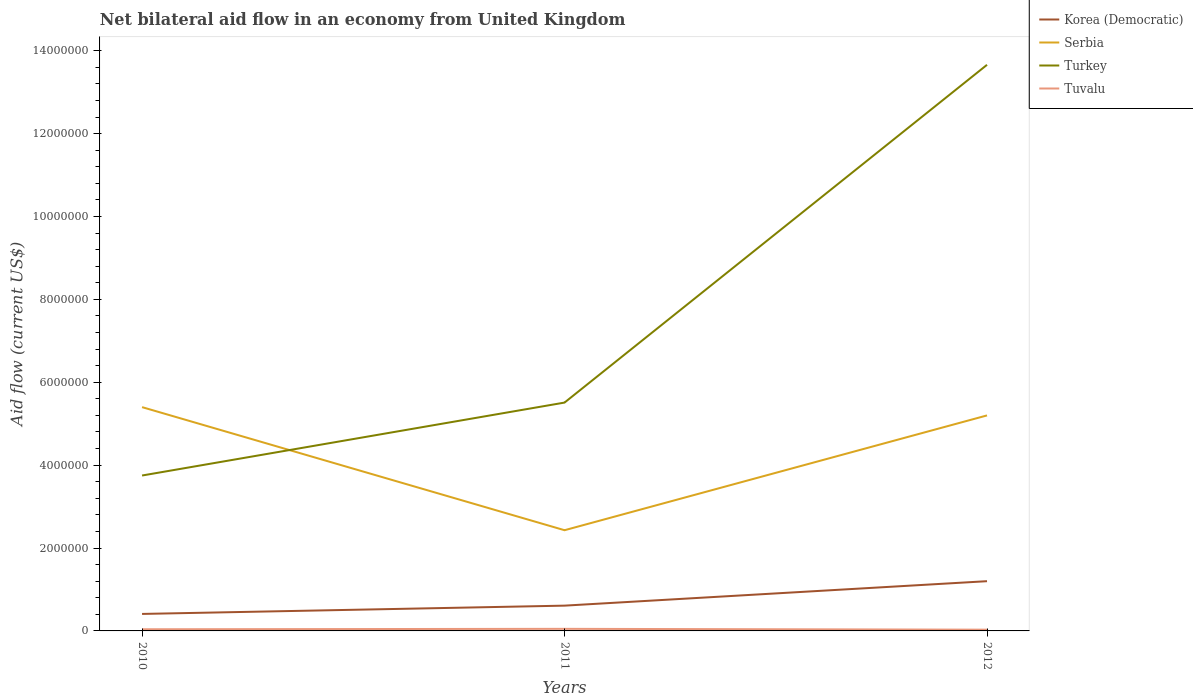Does the line corresponding to Turkey intersect with the line corresponding to Serbia?
Provide a short and direct response. Yes. Is the number of lines equal to the number of legend labels?
Provide a short and direct response. Yes. Across all years, what is the maximum net bilateral aid flow in Turkey?
Offer a very short reply. 3.75e+06. In which year was the net bilateral aid flow in Serbia maximum?
Give a very brief answer. 2011. What is the total net bilateral aid flow in Serbia in the graph?
Keep it short and to the point. -2.77e+06. What is the difference between the highest and the second highest net bilateral aid flow in Turkey?
Offer a very short reply. 9.91e+06. What is the difference between the highest and the lowest net bilateral aid flow in Tuvalu?
Keep it short and to the point. 1. Is the net bilateral aid flow in Korea (Democratic) strictly greater than the net bilateral aid flow in Tuvalu over the years?
Keep it short and to the point. No. How many years are there in the graph?
Provide a succinct answer. 3. What is the difference between two consecutive major ticks on the Y-axis?
Your answer should be very brief. 2.00e+06. Does the graph contain grids?
Make the answer very short. No. Where does the legend appear in the graph?
Provide a succinct answer. Top right. How many legend labels are there?
Keep it short and to the point. 4. What is the title of the graph?
Offer a terse response. Net bilateral aid flow in an economy from United Kingdom. Does "Tajikistan" appear as one of the legend labels in the graph?
Offer a very short reply. No. What is the label or title of the X-axis?
Ensure brevity in your answer.  Years. What is the Aid flow (current US$) of Serbia in 2010?
Your response must be concise. 5.40e+06. What is the Aid flow (current US$) in Turkey in 2010?
Your answer should be compact. 3.75e+06. What is the Aid flow (current US$) of Tuvalu in 2010?
Provide a short and direct response. 4.00e+04. What is the Aid flow (current US$) in Serbia in 2011?
Offer a very short reply. 2.43e+06. What is the Aid flow (current US$) in Turkey in 2011?
Offer a terse response. 5.51e+06. What is the Aid flow (current US$) in Korea (Democratic) in 2012?
Make the answer very short. 1.20e+06. What is the Aid flow (current US$) in Serbia in 2012?
Your answer should be very brief. 5.20e+06. What is the Aid flow (current US$) in Turkey in 2012?
Offer a terse response. 1.37e+07. What is the Aid flow (current US$) of Tuvalu in 2012?
Ensure brevity in your answer.  3.00e+04. Across all years, what is the maximum Aid flow (current US$) of Korea (Democratic)?
Your response must be concise. 1.20e+06. Across all years, what is the maximum Aid flow (current US$) of Serbia?
Offer a terse response. 5.40e+06. Across all years, what is the maximum Aid flow (current US$) of Turkey?
Provide a short and direct response. 1.37e+07. Across all years, what is the maximum Aid flow (current US$) in Tuvalu?
Provide a succinct answer. 5.00e+04. Across all years, what is the minimum Aid flow (current US$) of Serbia?
Make the answer very short. 2.43e+06. Across all years, what is the minimum Aid flow (current US$) in Turkey?
Keep it short and to the point. 3.75e+06. What is the total Aid flow (current US$) in Korea (Democratic) in the graph?
Your answer should be compact. 2.22e+06. What is the total Aid flow (current US$) of Serbia in the graph?
Offer a very short reply. 1.30e+07. What is the total Aid flow (current US$) of Turkey in the graph?
Provide a succinct answer. 2.29e+07. What is the difference between the Aid flow (current US$) of Korea (Democratic) in 2010 and that in 2011?
Make the answer very short. -2.00e+05. What is the difference between the Aid flow (current US$) in Serbia in 2010 and that in 2011?
Ensure brevity in your answer.  2.97e+06. What is the difference between the Aid flow (current US$) of Turkey in 2010 and that in 2011?
Provide a succinct answer. -1.76e+06. What is the difference between the Aid flow (current US$) in Tuvalu in 2010 and that in 2011?
Your response must be concise. -10000. What is the difference between the Aid flow (current US$) in Korea (Democratic) in 2010 and that in 2012?
Provide a succinct answer. -7.90e+05. What is the difference between the Aid flow (current US$) of Turkey in 2010 and that in 2012?
Ensure brevity in your answer.  -9.91e+06. What is the difference between the Aid flow (current US$) in Korea (Democratic) in 2011 and that in 2012?
Give a very brief answer. -5.90e+05. What is the difference between the Aid flow (current US$) of Serbia in 2011 and that in 2012?
Provide a short and direct response. -2.77e+06. What is the difference between the Aid flow (current US$) in Turkey in 2011 and that in 2012?
Provide a succinct answer. -8.15e+06. What is the difference between the Aid flow (current US$) in Korea (Democratic) in 2010 and the Aid flow (current US$) in Serbia in 2011?
Your response must be concise. -2.02e+06. What is the difference between the Aid flow (current US$) in Korea (Democratic) in 2010 and the Aid flow (current US$) in Turkey in 2011?
Your answer should be very brief. -5.10e+06. What is the difference between the Aid flow (current US$) in Korea (Democratic) in 2010 and the Aid flow (current US$) in Tuvalu in 2011?
Make the answer very short. 3.60e+05. What is the difference between the Aid flow (current US$) in Serbia in 2010 and the Aid flow (current US$) in Turkey in 2011?
Offer a terse response. -1.10e+05. What is the difference between the Aid flow (current US$) in Serbia in 2010 and the Aid flow (current US$) in Tuvalu in 2011?
Offer a very short reply. 5.35e+06. What is the difference between the Aid flow (current US$) of Turkey in 2010 and the Aid flow (current US$) of Tuvalu in 2011?
Your answer should be very brief. 3.70e+06. What is the difference between the Aid flow (current US$) in Korea (Democratic) in 2010 and the Aid flow (current US$) in Serbia in 2012?
Offer a terse response. -4.79e+06. What is the difference between the Aid flow (current US$) in Korea (Democratic) in 2010 and the Aid flow (current US$) in Turkey in 2012?
Your answer should be compact. -1.32e+07. What is the difference between the Aid flow (current US$) of Serbia in 2010 and the Aid flow (current US$) of Turkey in 2012?
Give a very brief answer. -8.26e+06. What is the difference between the Aid flow (current US$) in Serbia in 2010 and the Aid flow (current US$) in Tuvalu in 2012?
Your response must be concise. 5.37e+06. What is the difference between the Aid flow (current US$) of Turkey in 2010 and the Aid flow (current US$) of Tuvalu in 2012?
Keep it short and to the point. 3.72e+06. What is the difference between the Aid flow (current US$) in Korea (Democratic) in 2011 and the Aid flow (current US$) in Serbia in 2012?
Your answer should be compact. -4.59e+06. What is the difference between the Aid flow (current US$) of Korea (Democratic) in 2011 and the Aid flow (current US$) of Turkey in 2012?
Keep it short and to the point. -1.30e+07. What is the difference between the Aid flow (current US$) of Korea (Democratic) in 2011 and the Aid flow (current US$) of Tuvalu in 2012?
Your response must be concise. 5.80e+05. What is the difference between the Aid flow (current US$) of Serbia in 2011 and the Aid flow (current US$) of Turkey in 2012?
Provide a short and direct response. -1.12e+07. What is the difference between the Aid flow (current US$) of Serbia in 2011 and the Aid flow (current US$) of Tuvalu in 2012?
Offer a very short reply. 2.40e+06. What is the difference between the Aid flow (current US$) in Turkey in 2011 and the Aid flow (current US$) in Tuvalu in 2012?
Your response must be concise. 5.48e+06. What is the average Aid flow (current US$) of Korea (Democratic) per year?
Your response must be concise. 7.40e+05. What is the average Aid flow (current US$) of Serbia per year?
Ensure brevity in your answer.  4.34e+06. What is the average Aid flow (current US$) of Turkey per year?
Provide a succinct answer. 7.64e+06. In the year 2010, what is the difference between the Aid flow (current US$) in Korea (Democratic) and Aid flow (current US$) in Serbia?
Your answer should be very brief. -4.99e+06. In the year 2010, what is the difference between the Aid flow (current US$) of Korea (Democratic) and Aid flow (current US$) of Turkey?
Your answer should be compact. -3.34e+06. In the year 2010, what is the difference between the Aid flow (current US$) of Serbia and Aid flow (current US$) of Turkey?
Your answer should be compact. 1.65e+06. In the year 2010, what is the difference between the Aid flow (current US$) of Serbia and Aid flow (current US$) of Tuvalu?
Keep it short and to the point. 5.36e+06. In the year 2010, what is the difference between the Aid flow (current US$) in Turkey and Aid flow (current US$) in Tuvalu?
Your answer should be very brief. 3.71e+06. In the year 2011, what is the difference between the Aid flow (current US$) of Korea (Democratic) and Aid flow (current US$) of Serbia?
Keep it short and to the point. -1.82e+06. In the year 2011, what is the difference between the Aid flow (current US$) in Korea (Democratic) and Aid flow (current US$) in Turkey?
Keep it short and to the point. -4.90e+06. In the year 2011, what is the difference between the Aid flow (current US$) in Korea (Democratic) and Aid flow (current US$) in Tuvalu?
Your response must be concise. 5.60e+05. In the year 2011, what is the difference between the Aid flow (current US$) of Serbia and Aid flow (current US$) of Turkey?
Give a very brief answer. -3.08e+06. In the year 2011, what is the difference between the Aid flow (current US$) in Serbia and Aid flow (current US$) in Tuvalu?
Ensure brevity in your answer.  2.38e+06. In the year 2011, what is the difference between the Aid flow (current US$) of Turkey and Aid flow (current US$) of Tuvalu?
Make the answer very short. 5.46e+06. In the year 2012, what is the difference between the Aid flow (current US$) of Korea (Democratic) and Aid flow (current US$) of Turkey?
Provide a succinct answer. -1.25e+07. In the year 2012, what is the difference between the Aid flow (current US$) in Korea (Democratic) and Aid flow (current US$) in Tuvalu?
Provide a short and direct response. 1.17e+06. In the year 2012, what is the difference between the Aid flow (current US$) in Serbia and Aid flow (current US$) in Turkey?
Give a very brief answer. -8.46e+06. In the year 2012, what is the difference between the Aid flow (current US$) of Serbia and Aid flow (current US$) of Tuvalu?
Keep it short and to the point. 5.17e+06. In the year 2012, what is the difference between the Aid flow (current US$) of Turkey and Aid flow (current US$) of Tuvalu?
Offer a very short reply. 1.36e+07. What is the ratio of the Aid flow (current US$) of Korea (Democratic) in 2010 to that in 2011?
Ensure brevity in your answer.  0.67. What is the ratio of the Aid flow (current US$) in Serbia in 2010 to that in 2011?
Provide a short and direct response. 2.22. What is the ratio of the Aid flow (current US$) in Turkey in 2010 to that in 2011?
Provide a succinct answer. 0.68. What is the ratio of the Aid flow (current US$) of Tuvalu in 2010 to that in 2011?
Offer a very short reply. 0.8. What is the ratio of the Aid flow (current US$) of Korea (Democratic) in 2010 to that in 2012?
Make the answer very short. 0.34. What is the ratio of the Aid flow (current US$) in Turkey in 2010 to that in 2012?
Ensure brevity in your answer.  0.27. What is the ratio of the Aid flow (current US$) of Korea (Democratic) in 2011 to that in 2012?
Give a very brief answer. 0.51. What is the ratio of the Aid flow (current US$) in Serbia in 2011 to that in 2012?
Give a very brief answer. 0.47. What is the ratio of the Aid flow (current US$) of Turkey in 2011 to that in 2012?
Your response must be concise. 0.4. What is the ratio of the Aid flow (current US$) in Tuvalu in 2011 to that in 2012?
Your answer should be very brief. 1.67. What is the difference between the highest and the second highest Aid flow (current US$) in Korea (Democratic)?
Provide a succinct answer. 5.90e+05. What is the difference between the highest and the second highest Aid flow (current US$) of Turkey?
Make the answer very short. 8.15e+06. What is the difference between the highest and the second highest Aid flow (current US$) in Tuvalu?
Ensure brevity in your answer.  10000. What is the difference between the highest and the lowest Aid flow (current US$) in Korea (Democratic)?
Your answer should be compact. 7.90e+05. What is the difference between the highest and the lowest Aid flow (current US$) in Serbia?
Offer a very short reply. 2.97e+06. What is the difference between the highest and the lowest Aid flow (current US$) in Turkey?
Provide a short and direct response. 9.91e+06. 